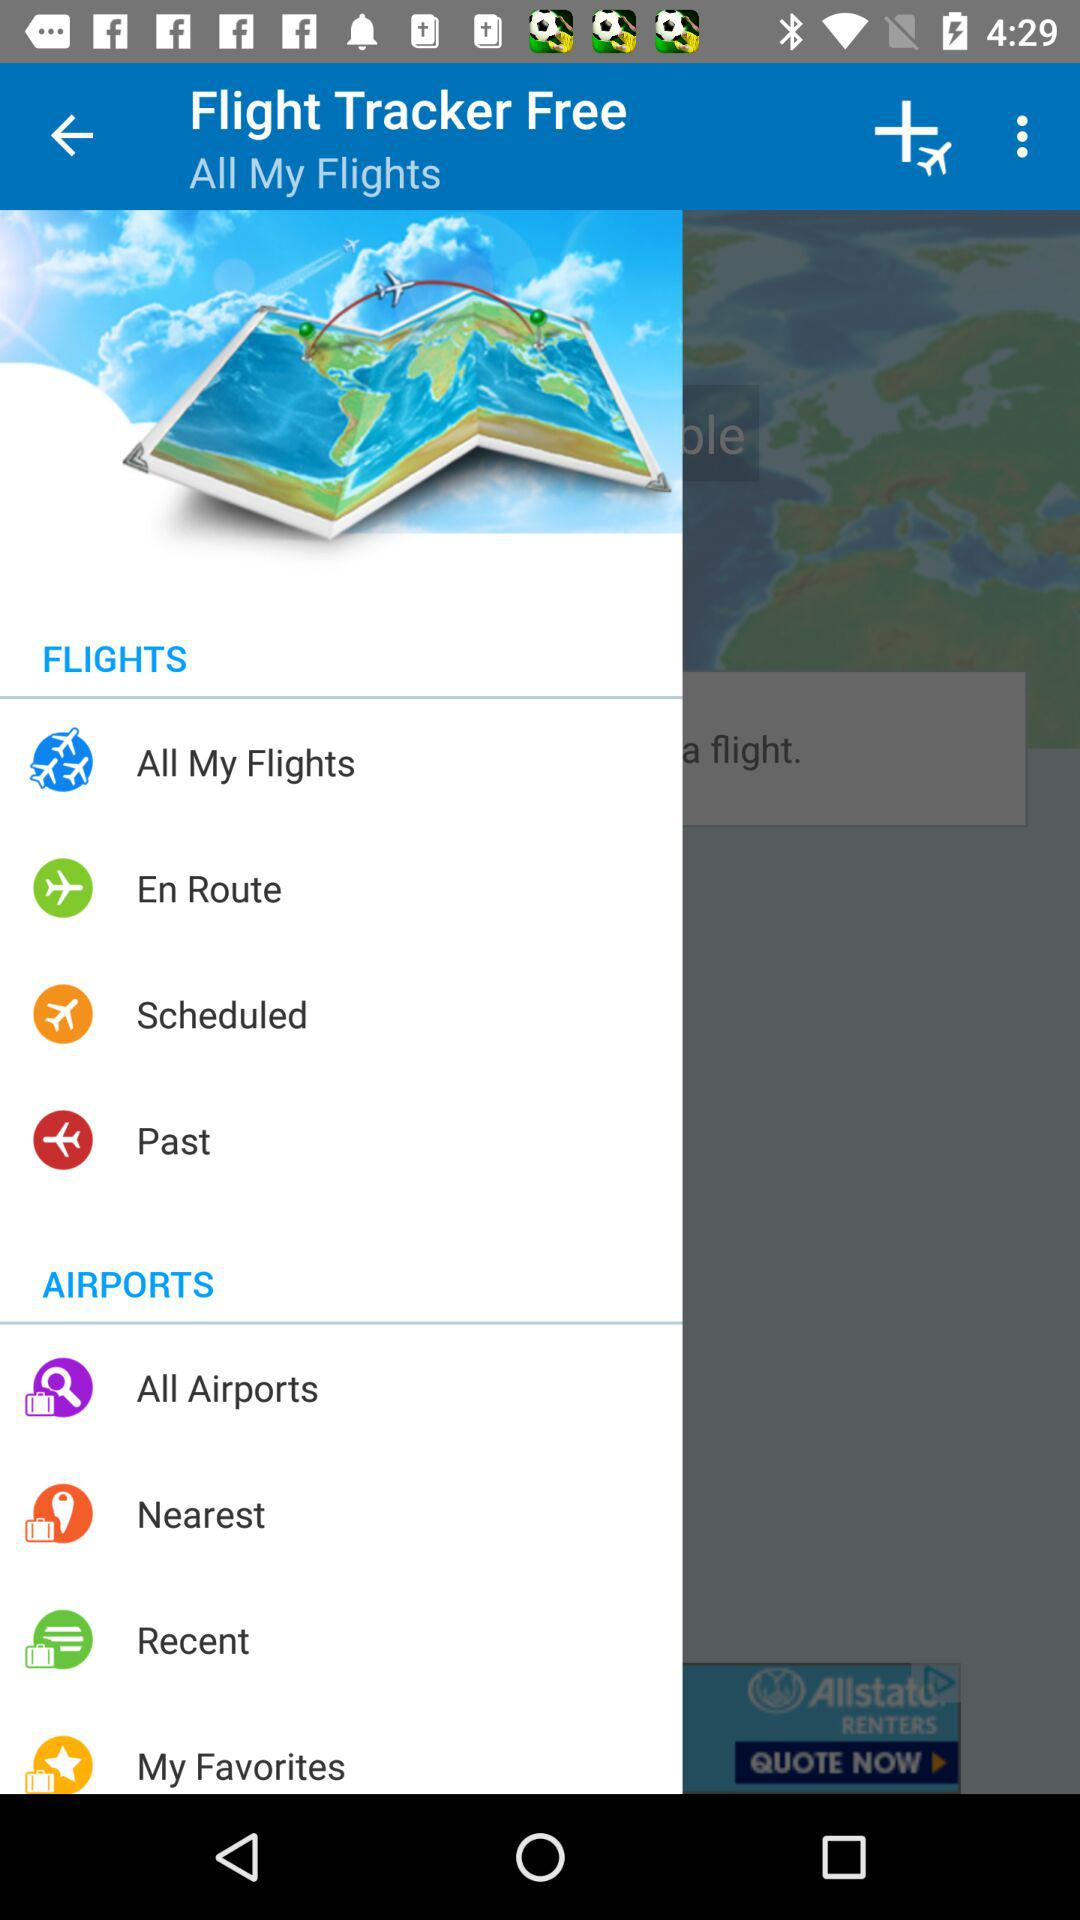What is the name of the application? The name of the application is Flight Tracker Free. 